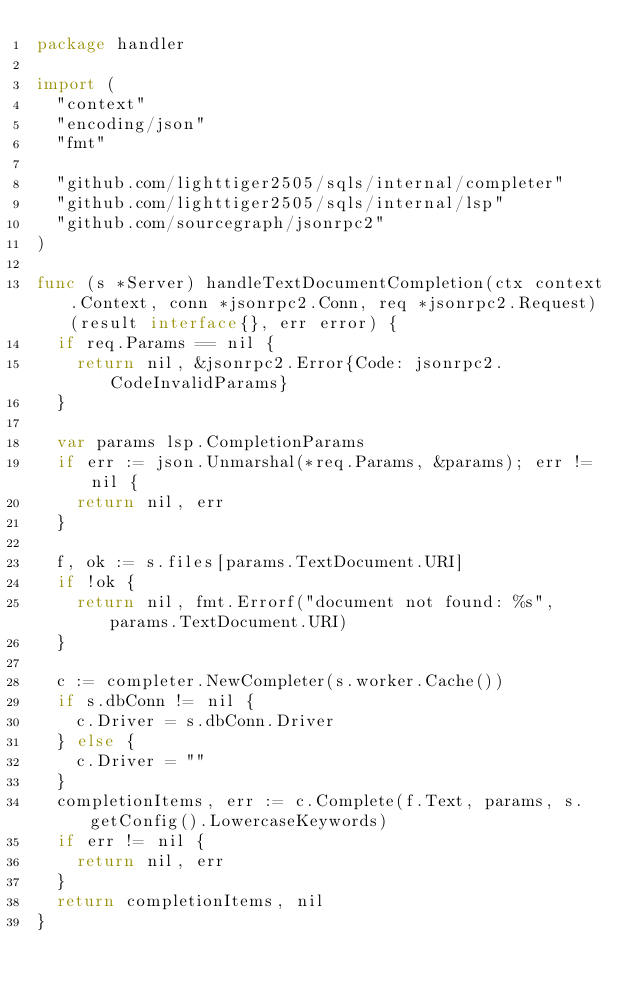Convert code to text. <code><loc_0><loc_0><loc_500><loc_500><_Go_>package handler

import (
	"context"
	"encoding/json"
	"fmt"

	"github.com/lighttiger2505/sqls/internal/completer"
	"github.com/lighttiger2505/sqls/internal/lsp"
	"github.com/sourcegraph/jsonrpc2"
)

func (s *Server) handleTextDocumentCompletion(ctx context.Context, conn *jsonrpc2.Conn, req *jsonrpc2.Request) (result interface{}, err error) {
	if req.Params == nil {
		return nil, &jsonrpc2.Error{Code: jsonrpc2.CodeInvalidParams}
	}

	var params lsp.CompletionParams
	if err := json.Unmarshal(*req.Params, &params); err != nil {
		return nil, err
	}

	f, ok := s.files[params.TextDocument.URI]
	if !ok {
		return nil, fmt.Errorf("document not found: %s", params.TextDocument.URI)
	}

	c := completer.NewCompleter(s.worker.Cache())
	if s.dbConn != nil {
		c.Driver = s.dbConn.Driver
	} else {
		c.Driver = ""
	}
	completionItems, err := c.Complete(f.Text, params, s.getConfig().LowercaseKeywords)
	if err != nil {
		return nil, err
	}
	return completionItems, nil
}
</code> 